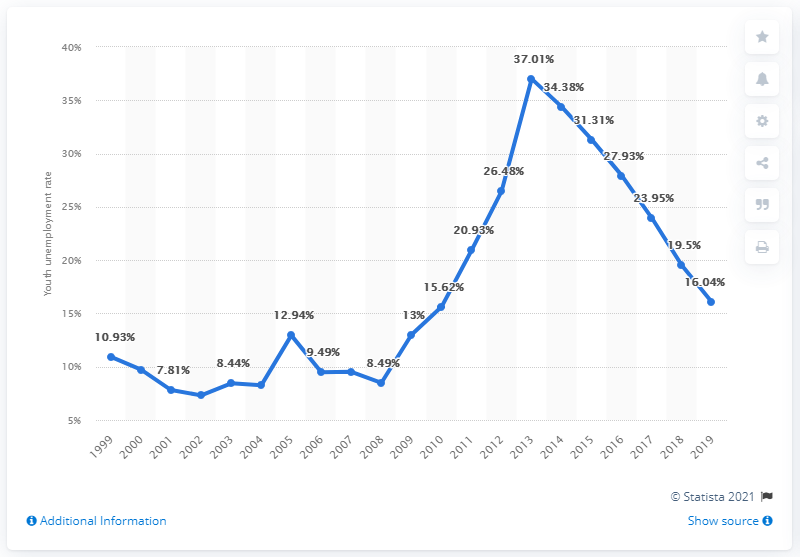Specify some key components in this picture. In 2019, the youth unemployment rate in Cyprus was 16.04%. 